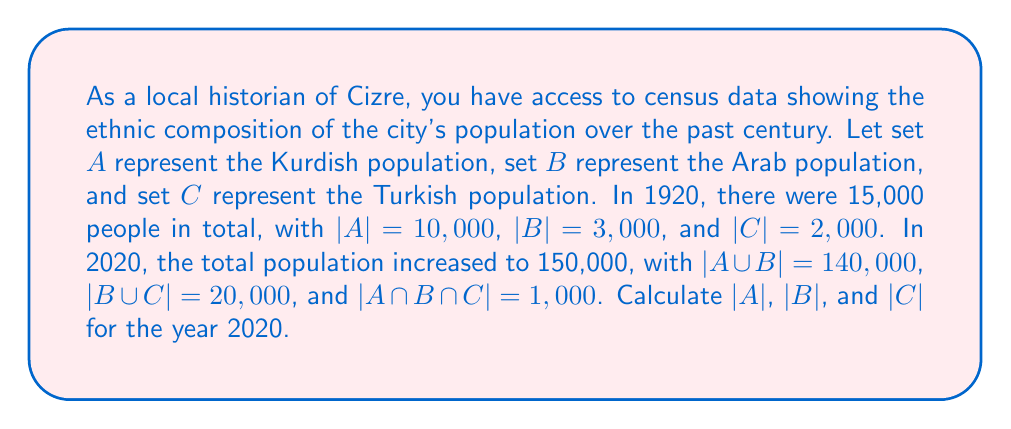Can you solve this math problem? To solve this problem, we'll use the inclusion-exclusion principle and the given information:

1. Total population in 2020: 150,000
2. |A ∪ B| = 140,000
3. |B ∪ C| = 20,000
4. |A ∩ B ∩ C| = 1,000

Let's start by finding |A ∩ B|:
$$ |A ∪ B| = |A| + |B| - |A ∩ B| $$
$$ 140,000 = |A| + |B| - |A ∩ B| \quad (1) $$

Now, let's use the total population to create another equation:
$$ |A ∪ B ∪ C| = |A| + |B| + |C| - |A ∩ B| - |B ∩ C| - |A ∩ C| + |A ∩ B ∩ C| $$
$$ 150,000 = |A| + |B| + |C| - |A ∩ B| - |B ∩ C| - |A ∩ C| + 1,000 \quad (2) $$

From |B ∪ C| = 20,000, we can deduce:
$$ 20,000 = |B| + |C| - |B ∩ C| $$
$$ |B ∩ C| = |B| + |C| - 20,000 \quad (3) $$

Substituting (1) and (3) into (2):
$$ 150,000 = 140,000 + |C| - (|B| + |C| - 20,000) - |A ∩ C| + 1,000 $$
$$ 150,000 = 140,000 + |C| - |B| - |C| + 20,000 - |A ∩ C| + 1,000 $$
$$ -11,000 = -|B| - |A ∩ C| $$
$$ |B| + |A ∩ C| = 11,000 \quad (4) $$

Now, from |A ∪ B| = 140,000 and the total population of 150,000, we can deduce:
$$ |C| - |A ∩ C| - |B ∩ C| + |A ∩ B ∩ C| = 10,000 $$
$$ |C| - |A ∩ C| - (|B| + |C| - 20,000) + 1,000 = 10,000 $$
$$ -|A ∩ C| - |B| + 20,000 + 1,000 = 10,000 $$
$$ |A ∩ C| + |B| = 11,000 \quad (5) $$

From (4) and (5), we can conclude that |A ∩ C| = |B| = 5,500.

Substituting this back into (1):
$$ 140,000 = |A| + 5,500 - |A ∩ B| $$
$$ |A| - |A ∩ B| = 134,500 \quad (6) $$

From |B ∪ C| = 20,000 and |B| = 5,500, we can deduce:
$$ |C| = 20,000 - 5,500 + |B ∩ C| = 14,500 + |B ∩ C| $$

Now, using the total population:
$$ 150,000 = |A| + 5,500 + (14,500 + |B ∩ C|) - |A ∩ B| - |B ∩ C| - 5,500 + 1,000 $$
$$ 134,500 = |A| - |A ∩ B| $$

This confirms equation (6). Therefore, |A| = 134,500.
Answer: In 2020, |A| (Kurdish population) = 134,500, |B| (Arab population) = 5,500, and |C| (Turkish population) = 14,500. 